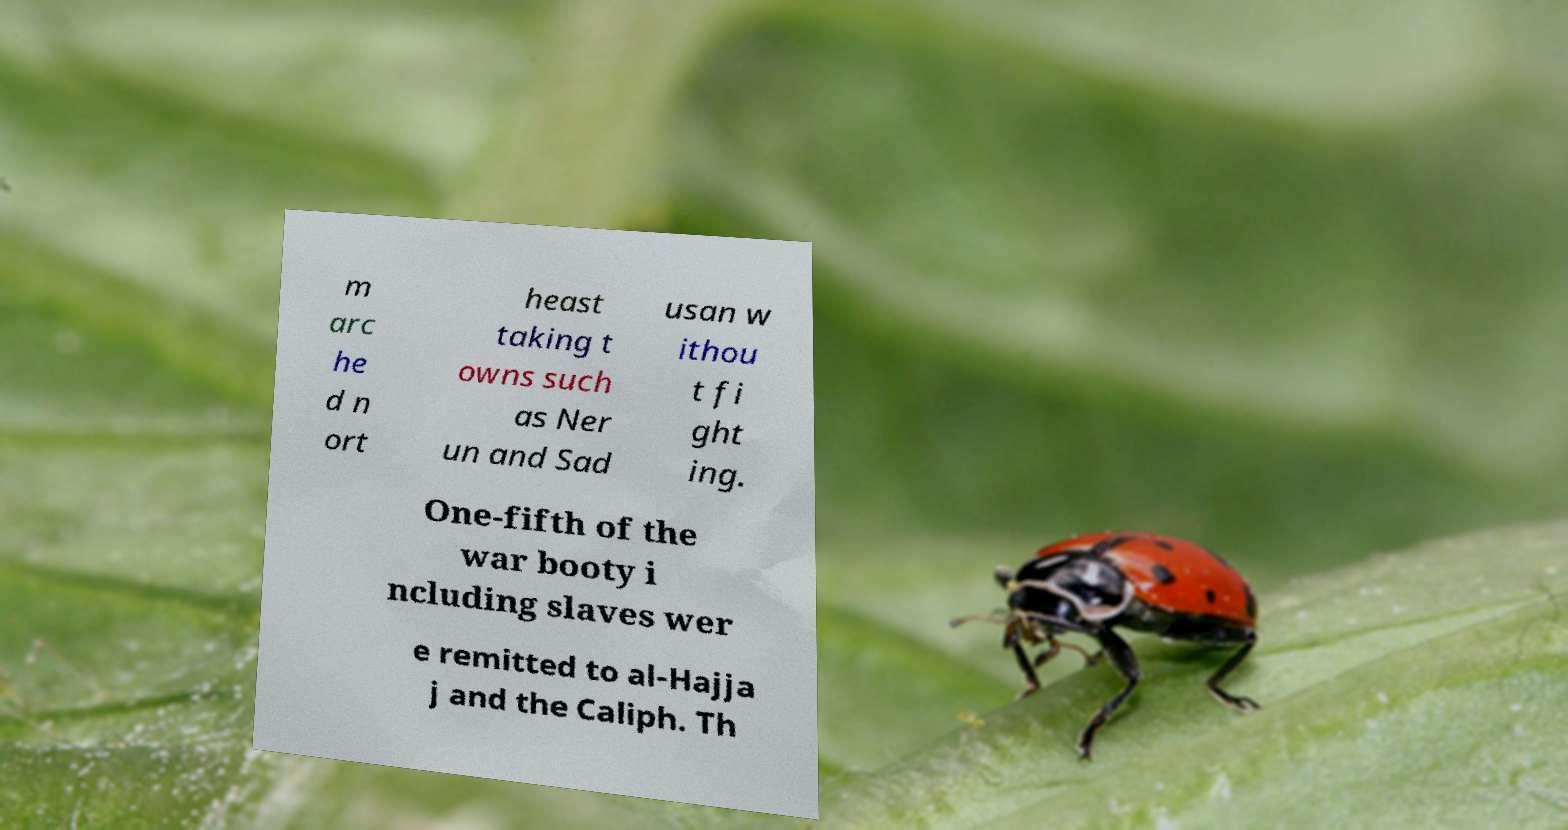Can you accurately transcribe the text from the provided image for me? m arc he d n ort heast taking t owns such as Ner un and Sad usan w ithou t fi ght ing. One-fifth of the war booty i ncluding slaves wer e remitted to al-Hajja j and the Caliph. Th 